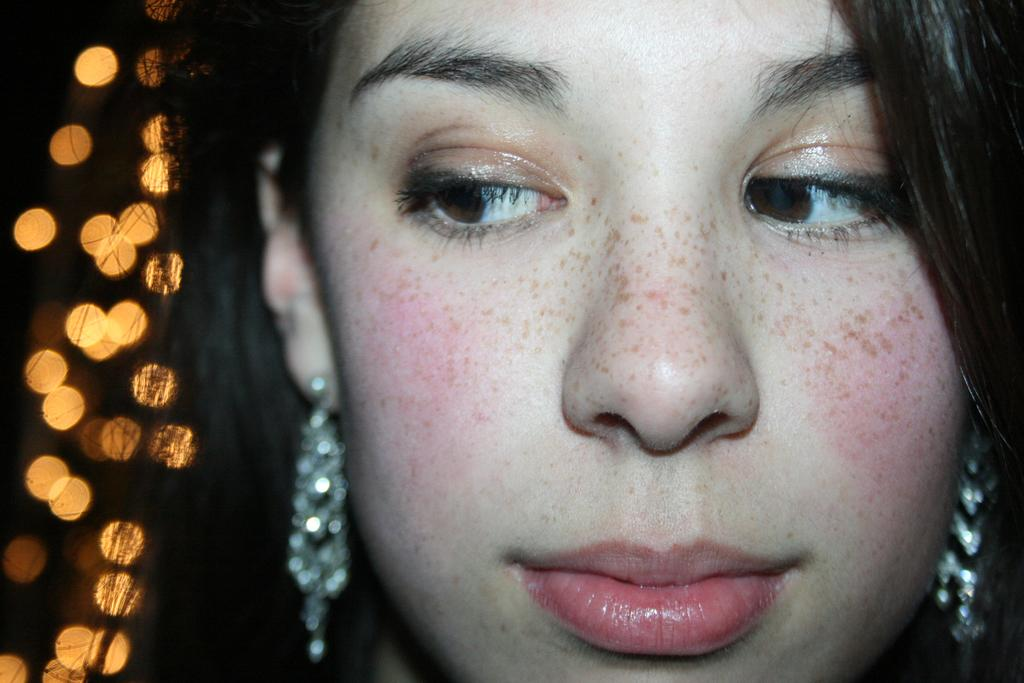What is the main subject of the image? There is a woman's face in the image. Can you describe the background of the image? There are lights in the background of the image. What type of design is featured on the woman's shirt in the image? There is no shirt visible in the image, as it only shows the woman's face. What government policies are mentioned in the image? There are no government policies mentioned in the image, as it only shows the woman's face and lights in the background. 